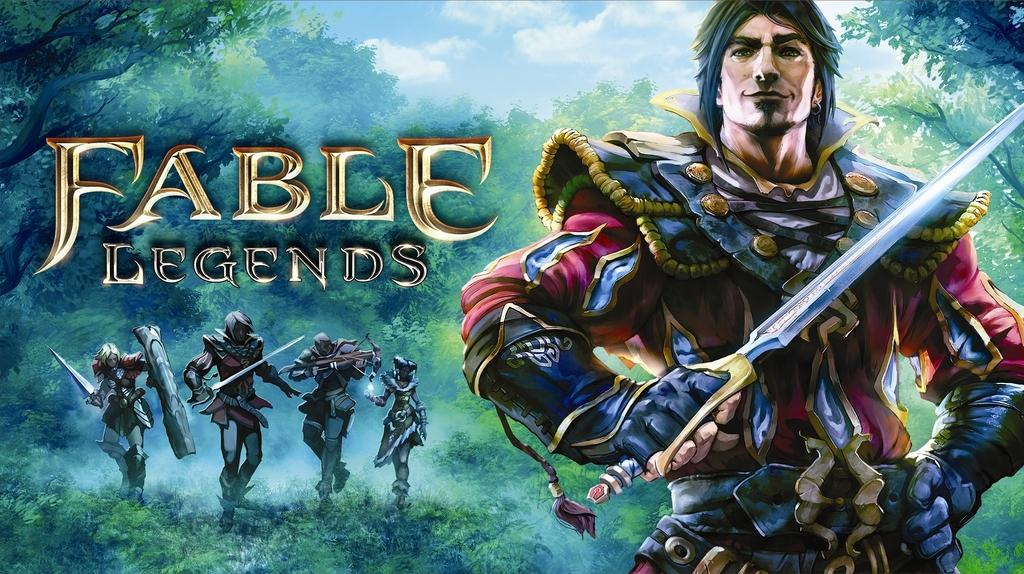<image>
Describe the image concisely. Artwork about the game Fable Legends showing a man with a sword. 